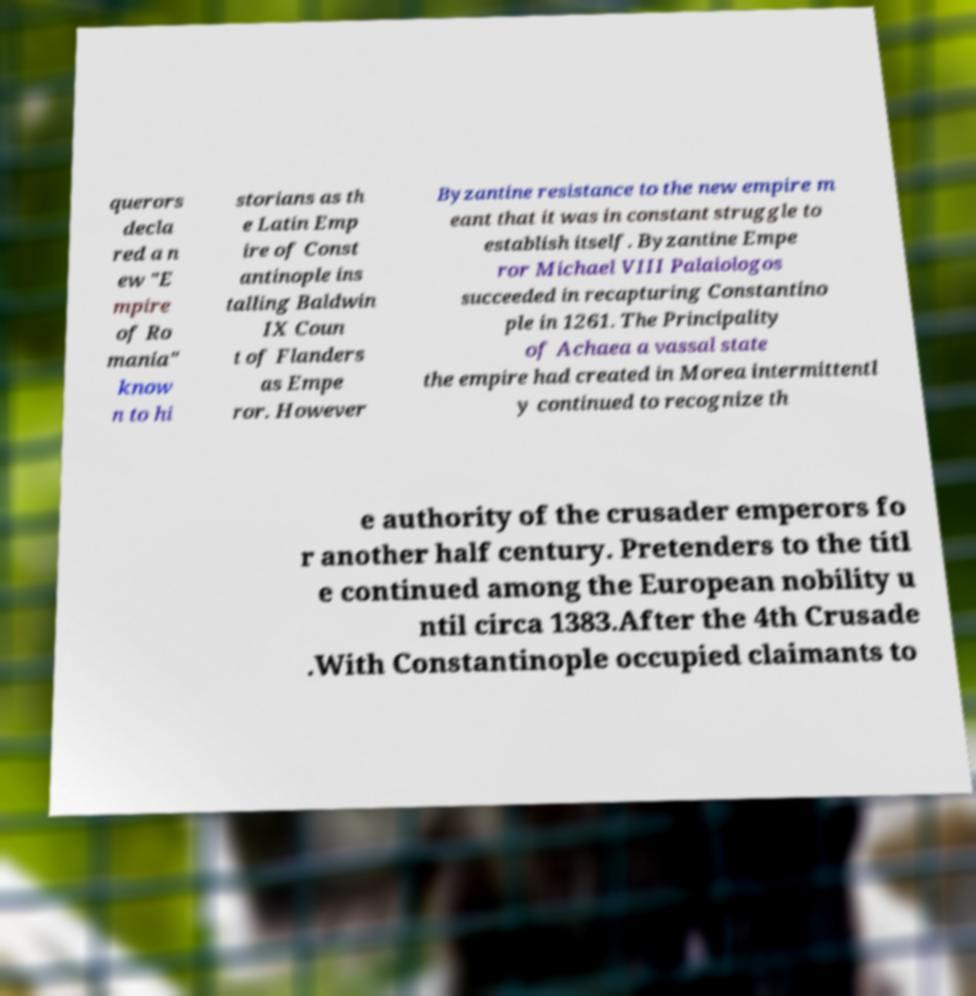Can you accurately transcribe the text from the provided image for me? querors decla red a n ew "E mpire of Ro mania" know n to hi storians as th e Latin Emp ire of Const antinople ins talling Baldwin IX Coun t of Flanders as Empe ror. However Byzantine resistance to the new empire m eant that it was in constant struggle to establish itself. Byzantine Empe ror Michael VIII Palaiologos succeeded in recapturing Constantino ple in 1261. The Principality of Achaea a vassal state the empire had created in Morea intermittentl y continued to recognize th e authority of the crusader emperors fo r another half century. Pretenders to the titl e continued among the European nobility u ntil circa 1383.After the 4th Crusade .With Constantinople occupied claimants to 